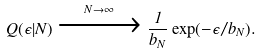<formula> <loc_0><loc_0><loc_500><loc_500>Q ( \epsilon | N ) \xrightarrow { N \rightarrow \infty } \frac { 1 } { b _ { N } } \exp ( - \epsilon / b _ { N } ) .</formula> 